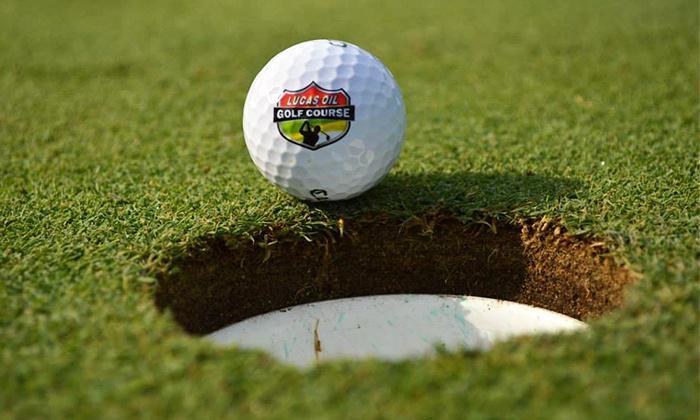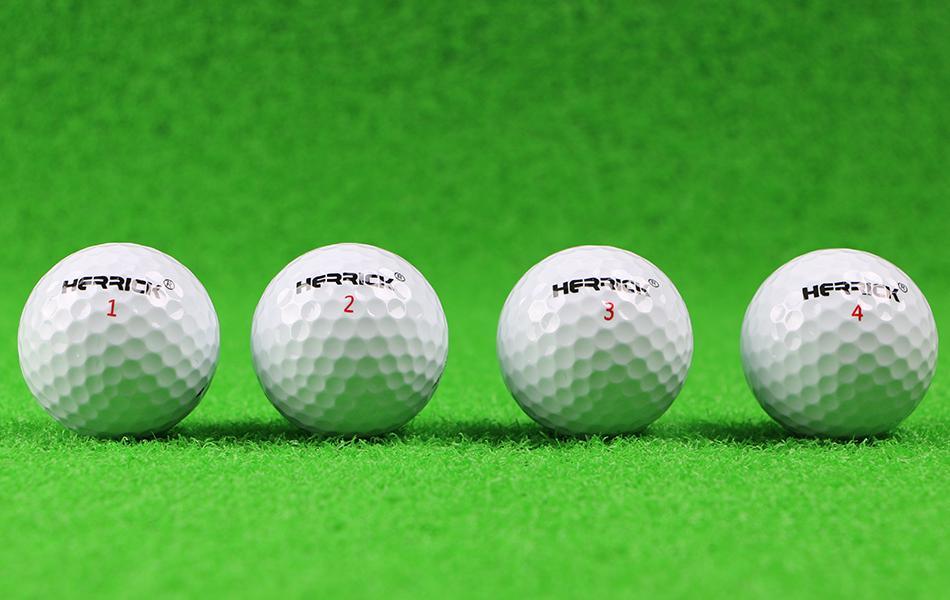The first image is the image on the left, the second image is the image on the right. For the images displayed, is the sentence "A golf club is behind at least one golf ball." factually correct? Answer yes or no. No. The first image is the image on the left, the second image is the image on the right. Considering the images on both sides, is "At least one image shows a golf ball on top of a tee." valid? Answer yes or no. No. 